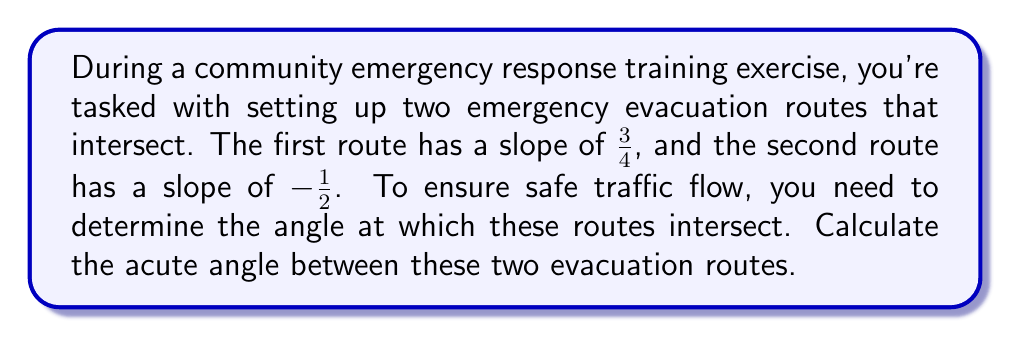Can you solve this math problem? Let's approach this step-by-step:

1) The formula for finding the angle $\theta$ between two lines with slopes $m_1$ and $m_2$ is:

   $$\tan \theta = \left|\frac{m_1 - m_2}{1 + m_1m_2}\right|$$

2) In this case, $m_1 = \frac{3}{4}$ and $m_2 = -\frac{1}{2}$

3) Let's substitute these values into the formula:

   $$\tan \theta = \left|\frac{\frac{3}{4} - (-\frac{1}{2})}{1 + \frac{3}{4}(-\frac{1}{2})}\right|$$

4) Simplify the numerator:
   $$\tan \theta = \left|\frac{\frac{3}{4} + \frac{1}{2}}{1 - \frac{3}{8}}\right|$$

5) Find a common denominator in the numerator:
   $$\tan \theta = \left|\frac{\frac{6}{8} + \frac{4}{8}}{1 - \frac{3}{8}}\right| = \left|\frac{\frac{10}{8}}{\frac{5}{8}}\right|$$

6) Divide the fractions:
   $$\tan \theta = \left|\frac{10}{5}\right| = 2$$

7) To find $\theta$, we need to take the inverse tangent (arctan or $\tan^{-1}$) of both sides:

   $$\theta = \tan^{-1}(2)$$

8) Using a calculator or trigonometric tables, we can find that:

   $$\theta \approx 63.43^\circ$$

This is the acute angle between the two evacuation routes.
Answer: The acute angle between the two evacuation routes is approximately $63.43^\circ$. 